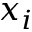Convert formula to latex. <formula><loc_0><loc_0><loc_500><loc_500>x _ { i }</formula> 